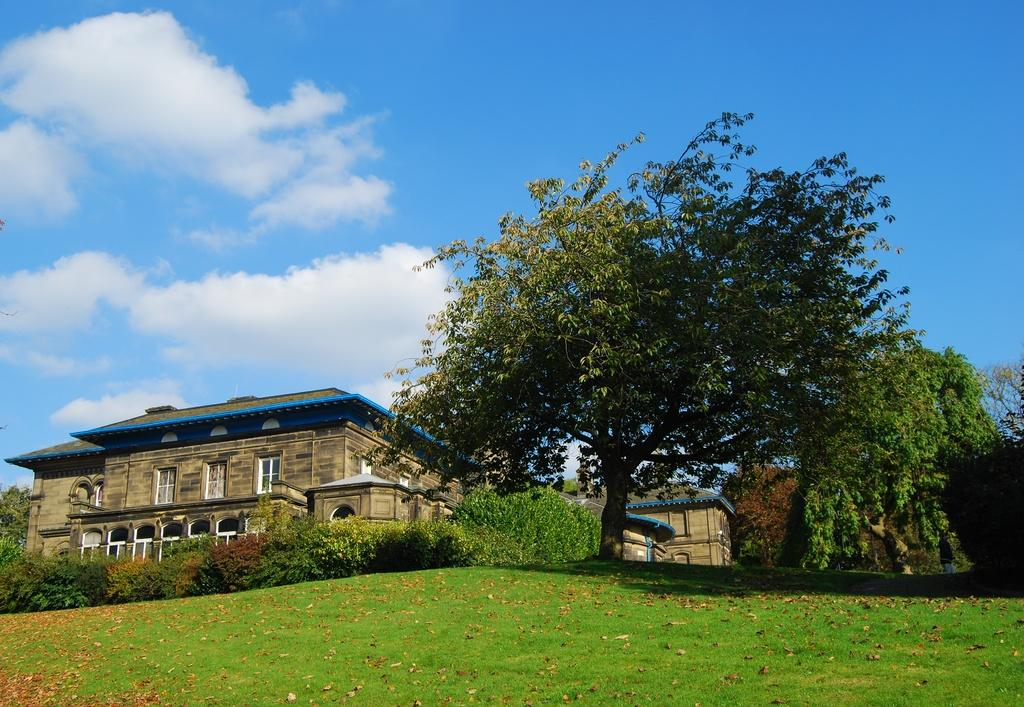What type of vegetation can be seen in the image? There are plants, grass, and trees in the image. What type of structures are present in the image? There are houses in the image. What is visible in the background of the image? The sky is visible in the background of the image. What can be seen in the sky? There are clouds in the sky. What color is the crayon used to draw the houses in the image? There is no crayon present in the image; the houses are depicted using photographic or illustrative techniques. How do the trees stretch towards the sky in the image? The trees do not stretch towards the sky in the image; they are depicted as standing upright. 